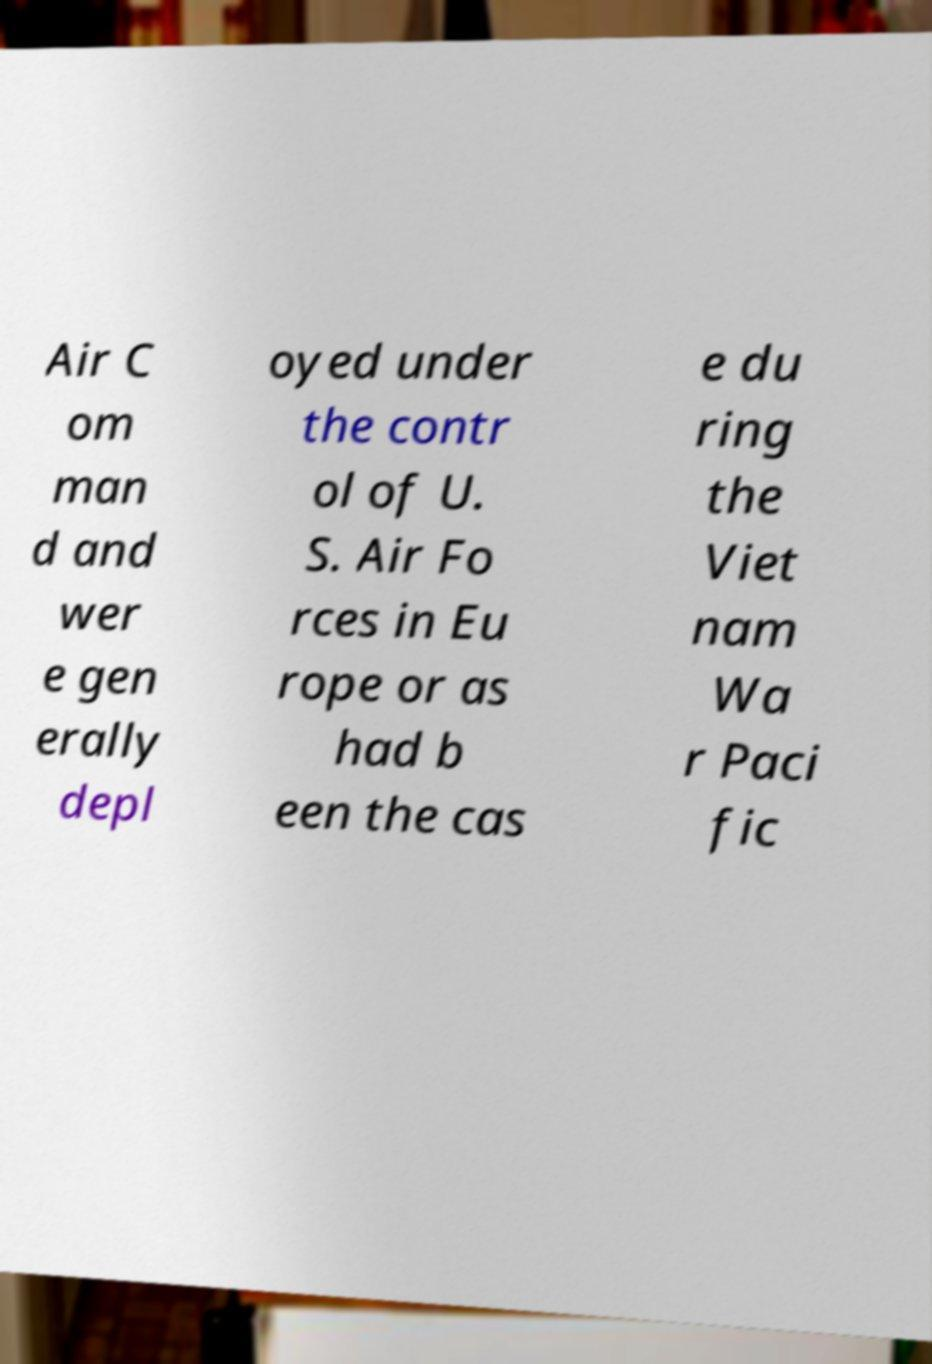Could you extract and type out the text from this image? Air C om man d and wer e gen erally depl oyed under the contr ol of U. S. Air Fo rces in Eu rope or as had b een the cas e du ring the Viet nam Wa r Paci fic 